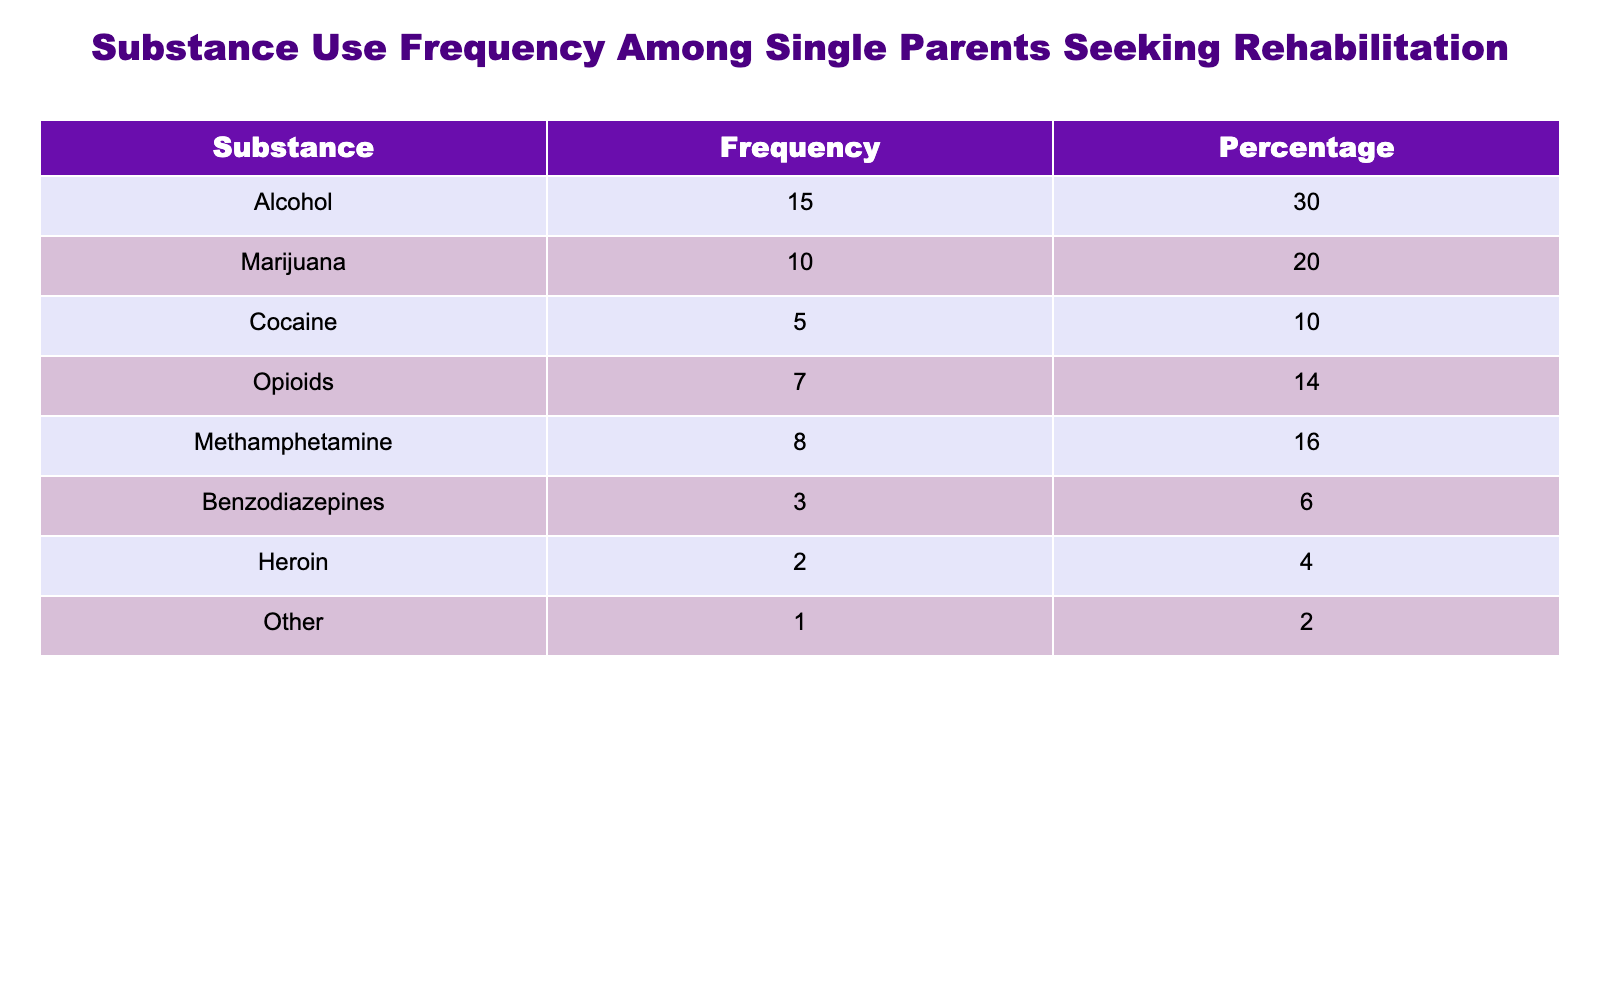What is the most commonly used substance among single parents seeking rehabilitation? The table indicates that Alcohol has the highest frequency of use at 15, compared to the other substances listed.
Answer: Alcohol What percentage of single parents use Methamphetamine? According to the table, Methamphetamine has a frequency of 8, which corresponds to a percentage of 16.
Answer: 16 Is the frequency of Benzodiazepines usage higher than that of Heroin? Benzodiazepines have a frequency of 3, while Heroin has a frequency of 2. Therefore, Benzodiazepines usage is indeed higher than that of Heroin.
Answer: Yes What is the total number of single parents using Opioids and Cocaine combined? The table shows that 7 single parents use Opioids and 5 use Cocaine. Adding these together gives a total of 7 + 5 = 12.
Answer: 12 What is the least common substance used among the single parents? The "Other" category shows a frequency of 1, making it the least commonly used substance in the table.
Answer: Other What percentage of single parents seek rehabilitation for substances other than Alcohol and Marijuana? The table lists Alcohol at 30% and Marijuana at 20%, so their combined percentage is 50%. To find the percentage for others, we subtract this from 100%, giving us 100% - 50% = 50%.
Answer: 50 How many more single parents use Marijuana than Heroin? Marijuana has a frequency of 10, while Heroin has a frequency of 2. The difference is 10 - 2 = 8.
Answer: 8 What is the combined percentage of single parents using Cocaine and Benzodiazepines? Cocaine has a percentage of 10% and Benzodiazepines has 6%. Adding these percentages gives us 10% + 6% = 16%.
Answer: 16 Are there more single parents using Opioids than those using Heroin and Other combined? Opioids have a frequency of 7, while Heroin has 2 and Other has 1. Adding Heroin and Other gives us 2 + 1 = 3. Since 7 > 3, the answer is yes.
Answer: Yes 